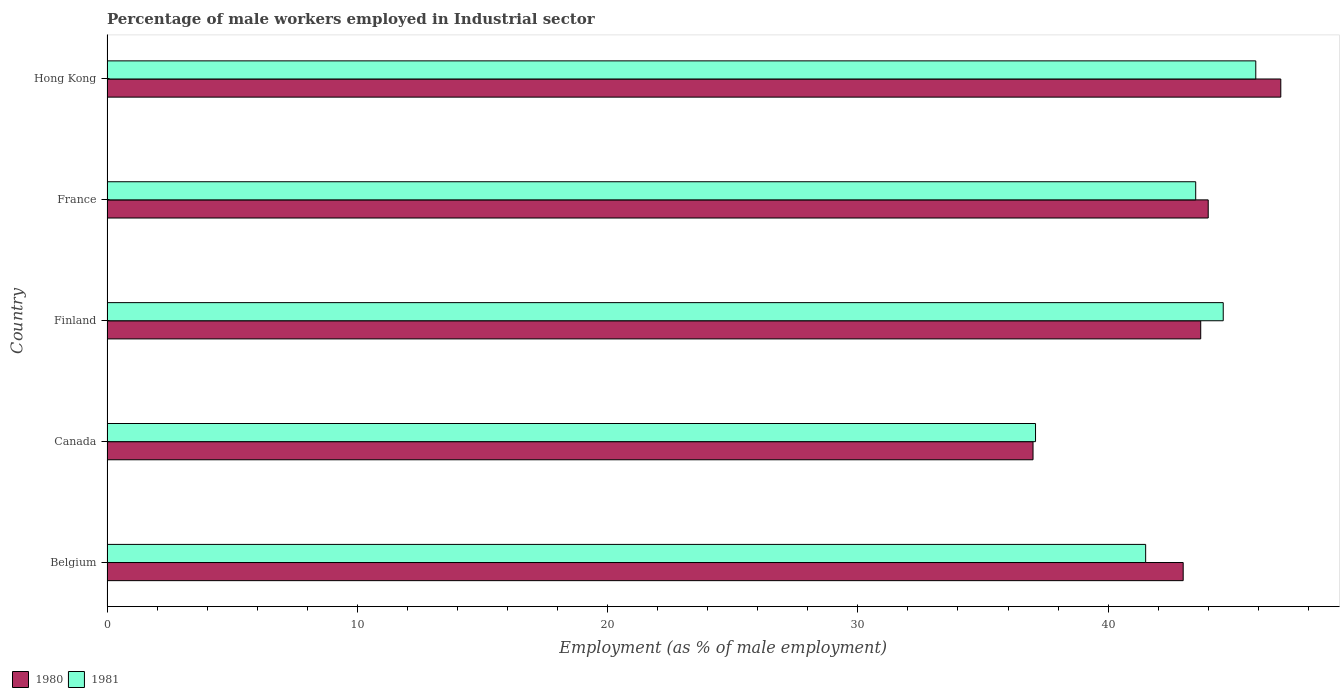How many groups of bars are there?
Your answer should be compact. 5. Are the number of bars on each tick of the Y-axis equal?
Provide a succinct answer. Yes. How many bars are there on the 4th tick from the top?
Offer a terse response. 2. How many bars are there on the 2nd tick from the bottom?
Give a very brief answer. 2. What is the label of the 4th group of bars from the top?
Make the answer very short. Canada. In how many cases, is the number of bars for a given country not equal to the number of legend labels?
Offer a terse response. 0. What is the percentage of male workers employed in Industrial sector in 1981 in Hong Kong?
Keep it short and to the point. 45.9. Across all countries, what is the maximum percentage of male workers employed in Industrial sector in 1981?
Make the answer very short. 45.9. Across all countries, what is the minimum percentage of male workers employed in Industrial sector in 1981?
Provide a short and direct response. 37.1. In which country was the percentage of male workers employed in Industrial sector in 1980 maximum?
Provide a succinct answer. Hong Kong. In which country was the percentage of male workers employed in Industrial sector in 1981 minimum?
Offer a very short reply. Canada. What is the total percentage of male workers employed in Industrial sector in 1980 in the graph?
Give a very brief answer. 214.6. What is the difference between the percentage of male workers employed in Industrial sector in 1981 in Finland and that in France?
Your answer should be very brief. 1.1. What is the difference between the percentage of male workers employed in Industrial sector in 1980 in Belgium and the percentage of male workers employed in Industrial sector in 1981 in Canada?
Ensure brevity in your answer.  5.9. What is the average percentage of male workers employed in Industrial sector in 1980 per country?
Provide a succinct answer. 42.92. What is the difference between the percentage of male workers employed in Industrial sector in 1980 and percentage of male workers employed in Industrial sector in 1981 in Canada?
Your answer should be compact. -0.1. In how many countries, is the percentage of male workers employed in Industrial sector in 1981 greater than 10 %?
Your answer should be very brief. 5. What is the ratio of the percentage of male workers employed in Industrial sector in 1981 in Belgium to that in Hong Kong?
Your answer should be compact. 0.9. Is the percentage of male workers employed in Industrial sector in 1980 in Canada less than that in Hong Kong?
Ensure brevity in your answer.  Yes. Is the difference between the percentage of male workers employed in Industrial sector in 1980 in Belgium and Canada greater than the difference between the percentage of male workers employed in Industrial sector in 1981 in Belgium and Canada?
Your response must be concise. Yes. What is the difference between the highest and the second highest percentage of male workers employed in Industrial sector in 1980?
Offer a very short reply. 2.9. What is the difference between the highest and the lowest percentage of male workers employed in Industrial sector in 1981?
Your response must be concise. 8.8. In how many countries, is the percentage of male workers employed in Industrial sector in 1980 greater than the average percentage of male workers employed in Industrial sector in 1980 taken over all countries?
Provide a succinct answer. 4. What does the 1st bar from the bottom in Finland represents?
Offer a very short reply. 1980. How many bars are there?
Provide a succinct answer. 10. Does the graph contain any zero values?
Provide a short and direct response. No. What is the title of the graph?
Your answer should be compact. Percentage of male workers employed in Industrial sector. Does "1960" appear as one of the legend labels in the graph?
Provide a succinct answer. No. What is the label or title of the X-axis?
Give a very brief answer. Employment (as % of male employment). What is the label or title of the Y-axis?
Keep it short and to the point. Country. What is the Employment (as % of male employment) in 1980 in Belgium?
Ensure brevity in your answer.  43. What is the Employment (as % of male employment) of 1981 in Belgium?
Offer a terse response. 41.5. What is the Employment (as % of male employment) of 1981 in Canada?
Your answer should be compact. 37.1. What is the Employment (as % of male employment) in 1980 in Finland?
Offer a terse response. 43.7. What is the Employment (as % of male employment) of 1981 in Finland?
Ensure brevity in your answer.  44.6. What is the Employment (as % of male employment) of 1980 in France?
Make the answer very short. 44. What is the Employment (as % of male employment) in 1981 in France?
Keep it short and to the point. 43.5. What is the Employment (as % of male employment) in 1980 in Hong Kong?
Make the answer very short. 46.9. What is the Employment (as % of male employment) of 1981 in Hong Kong?
Your answer should be very brief. 45.9. Across all countries, what is the maximum Employment (as % of male employment) in 1980?
Provide a short and direct response. 46.9. Across all countries, what is the maximum Employment (as % of male employment) of 1981?
Give a very brief answer. 45.9. Across all countries, what is the minimum Employment (as % of male employment) in 1981?
Provide a short and direct response. 37.1. What is the total Employment (as % of male employment) of 1980 in the graph?
Keep it short and to the point. 214.6. What is the total Employment (as % of male employment) of 1981 in the graph?
Offer a terse response. 212.6. What is the difference between the Employment (as % of male employment) of 1980 in Belgium and that in Hong Kong?
Your response must be concise. -3.9. What is the difference between the Employment (as % of male employment) in 1980 in Canada and that in Finland?
Your answer should be very brief. -6.7. What is the difference between the Employment (as % of male employment) of 1980 in Canada and that in France?
Make the answer very short. -7. What is the difference between the Employment (as % of male employment) in 1980 in Finland and that in France?
Ensure brevity in your answer.  -0.3. What is the difference between the Employment (as % of male employment) of 1980 in Finland and that in Hong Kong?
Make the answer very short. -3.2. What is the difference between the Employment (as % of male employment) of 1980 in France and that in Hong Kong?
Keep it short and to the point. -2.9. What is the difference between the Employment (as % of male employment) in 1980 in Belgium and the Employment (as % of male employment) in 1981 in Canada?
Your answer should be compact. 5.9. What is the difference between the Employment (as % of male employment) of 1980 in Canada and the Employment (as % of male employment) of 1981 in Hong Kong?
Your answer should be compact. -8.9. What is the difference between the Employment (as % of male employment) of 1980 in Finland and the Employment (as % of male employment) of 1981 in France?
Your answer should be very brief. 0.2. What is the difference between the Employment (as % of male employment) of 1980 in Finland and the Employment (as % of male employment) of 1981 in Hong Kong?
Offer a very short reply. -2.2. What is the difference between the Employment (as % of male employment) of 1980 in France and the Employment (as % of male employment) of 1981 in Hong Kong?
Give a very brief answer. -1.9. What is the average Employment (as % of male employment) in 1980 per country?
Offer a very short reply. 42.92. What is the average Employment (as % of male employment) of 1981 per country?
Provide a succinct answer. 42.52. What is the difference between the Employment (as % of male employment) in 1980 and Employment (as % of male employment) in 1981 in Belgium?
Your answer should be compact. 1.5. What is the difference between the Employment (as % of male employment) of 1980 and Employment (as % of male employment) of 1981 in Canada?
Keep it short and to the point. -0.1. What is the difference between the Employment (as % of male employment) in 1980 and Employment (as % of male employment) in 1981 in France?
Your answer should be very brief. 0.5. What is the difference between the Employment (as % of male employment) of 1980 and Employment (as % of male employment) of 1981 in Hong Kong?
Your answer should be very brief. 1. What is the ratio of the Employment (as % of male employment) of 1980 in Belgium to that in Canada?
Your answer should be very brief. 1.16. What is the ratio of the Employment (as % of male employment) in 1981 in Belgium to that in Canada?
Your answer should be very brief. 1.12. What is the ratio of the Employment (as % of male employment) of 1980 in Belgium to that in Finland?
Give a very brief answer. 0.98. What is the ratio of the Employment (as % of male employment) in 1981 in Belgium to that in Finland?
Provide a succinct answer. 0.93. What is the ratio of the Employment (as % of male employment) in 1980 in Belgium to that in France?
Your response must be concise. 0.98. What is the ratio of the Employment (as % of male employment) of 1981 in Belgium to that in France?
Provide a succinct answer. 0.95. What is the ratio of the Employment (as % of male employment) of 1980 in Belgium to that in Hong Kong?
Your answer should be very brief. 0.92. What is the ratio of the Employment (as % of male employment) in 1981 in Belgium to that in Hong Kong?
Provide a short and direct response. 0.9. What is the ratio of the Employment (as % of male employment) of 1980 in Canada to that in Finland?
Make the answer very short. 0.85. What is the ratio of the Employment (as % of male employment) of 1981 in Canada to that in Finland?
Provide a short and direct response. 0.83. What is the ratio of the Employment (as % of male employment) of 1980 in Canada to that in France?
Keep it short and to the point. 0.84. What is the ratio of the Employment (as % of male employment) of 1981 in Canada to that in France?
Give a very brief answer. 0.85. What is the ratio of the Employment (as % of male employment) of 1980 in Canada to that in Hong Kong?
Provide a succinct answer. 0.79. What is the ratio of the Employment (as % of male employment) of 1981 in Canada to that in Hong Kong?
Offer a terse response. 0.81. What is the ratio of the Employment (as % of male employment) of 1981 in Finland to that in France?
Provide a succinct answer. 1.03. What is the ratio of the Employment (as % of male employment) in 1980 in Finland to that in Hong Kong?
Your answer should be compact. 0.93. What is the ratio of the Employment (as % of male employment) of 1981 in Finland to that in Hong Kong?
Your answer should be compact. 0.97. What is the ratio of the Employment (as % of male employment) in 1980 in France to that in Hong Kong?
Give a very brief answer. 0.94. What is the ratio of the Employment (as % of male employment) in 1981 in France to that in Hong Kong?
Your response must be concise. 0.95. What is the difference between the highest and the second highest Employment (as % of male employment) in 1980?
Provide a short and direct response. 2.9. What is the difference between the highest and the second highest Employment (as % of male employment) of 1981?
Your answer should be compact. 1.3. What is the difference between the highest and the lowest Employment (as % of male employment) of 1980?
Ensure brevity in your answer.  9.9. 